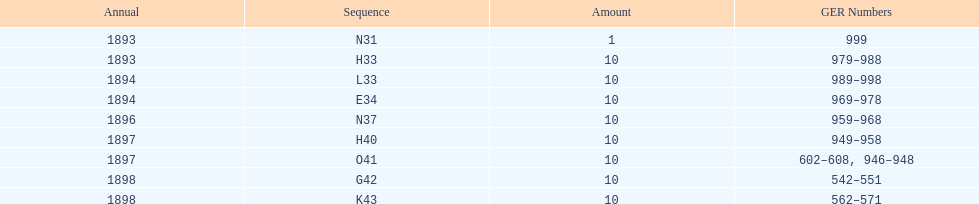Which year had the least ger numbers? 1893. 